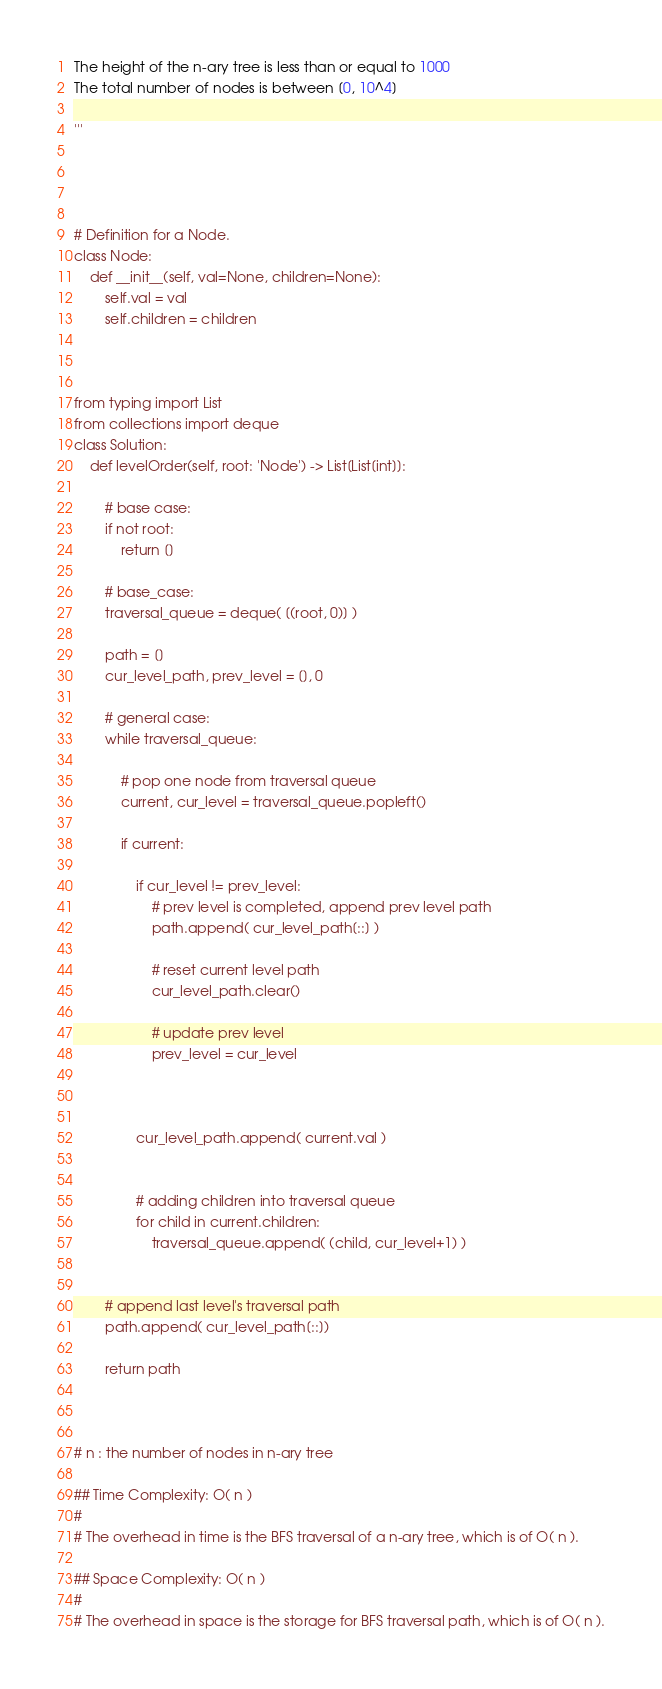<code> <loc_0><loc_0><loc_500><loc_500><_Python_>The height of the n-ary tree is less than or equal to 1000
The total number of nodes is between [0, 10^4]

'''




# Definition for a Node.
class Node:
    def __init__(self, val=None, children=None):
        self.val = val
        self.children = children



from typing import List
from collections import deque
class Solution:
    def levelOrder(self, root: 'Node') -> List[List[int]]:
        
        # base case:
        if not root:
            return []
        
        # base_case:
        traversal_queue = deque( [(root, 0)] )
        
        path = []
        cur_level_path, prev_level = [], 0
        
        # general case:
        while traversal_queue:
        
            # pop one node from traversal queue
            current, cur_level = traversal_queue.popleft()
            
            if current:
                
                if cur_level != prev_level:
                    # prev level is completed, append prev level path
                    path.append( cur_level_path[::] )
                    
                    # reset current level path
                    cur_level_path.clear()
                    
                    # update prev level 
                    prev_level = cur_level
                    
                
                
                cur_level_path.append( current.val )
                
                
                # adding children into traversal queue
                for child in current.children:
                    traversal_queue.append( (child, cur_level+1) )
                    
        
        # append last level's traversal path
        path.append( cur_level_path[::])

        return path



# n : the number of nodes in n-ary tree

## Time Complexity: O( n )
#
# The overhead in time is the BFS traversal of a n-ary tree, which is of O( n ).

## Space Complexity: O( n )
#
# The overhead in space is the storage for BFS traversal path, which is of O( n ).</code> 